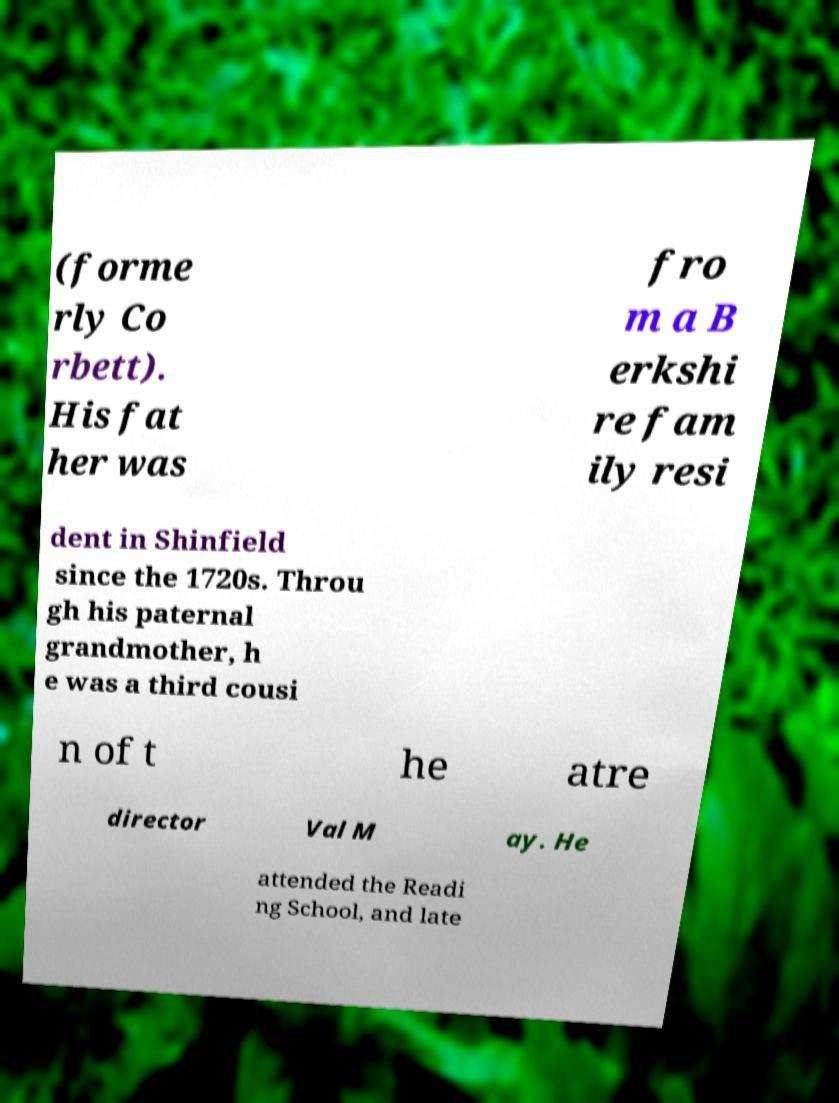Can you read and provide the text displayed in the image?This photo seems to have some interesting text. Can you extract and type it out for me? (forme rly Co rbett). His fat her was fro m a B erkshi re fam ily resi dent in Shinfield since the 1720s. Throu gh his paternal grandmother, h e was a third cousi n of t he atre director Val M ay. He attended the Readi ng School, and late 